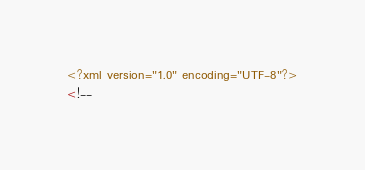Convert code to text. <code><loc_0><loc_0><loc_500><loc_500><_XML_><?xml version="1.0" encoding="UTF-8"?>
<!--</code> 